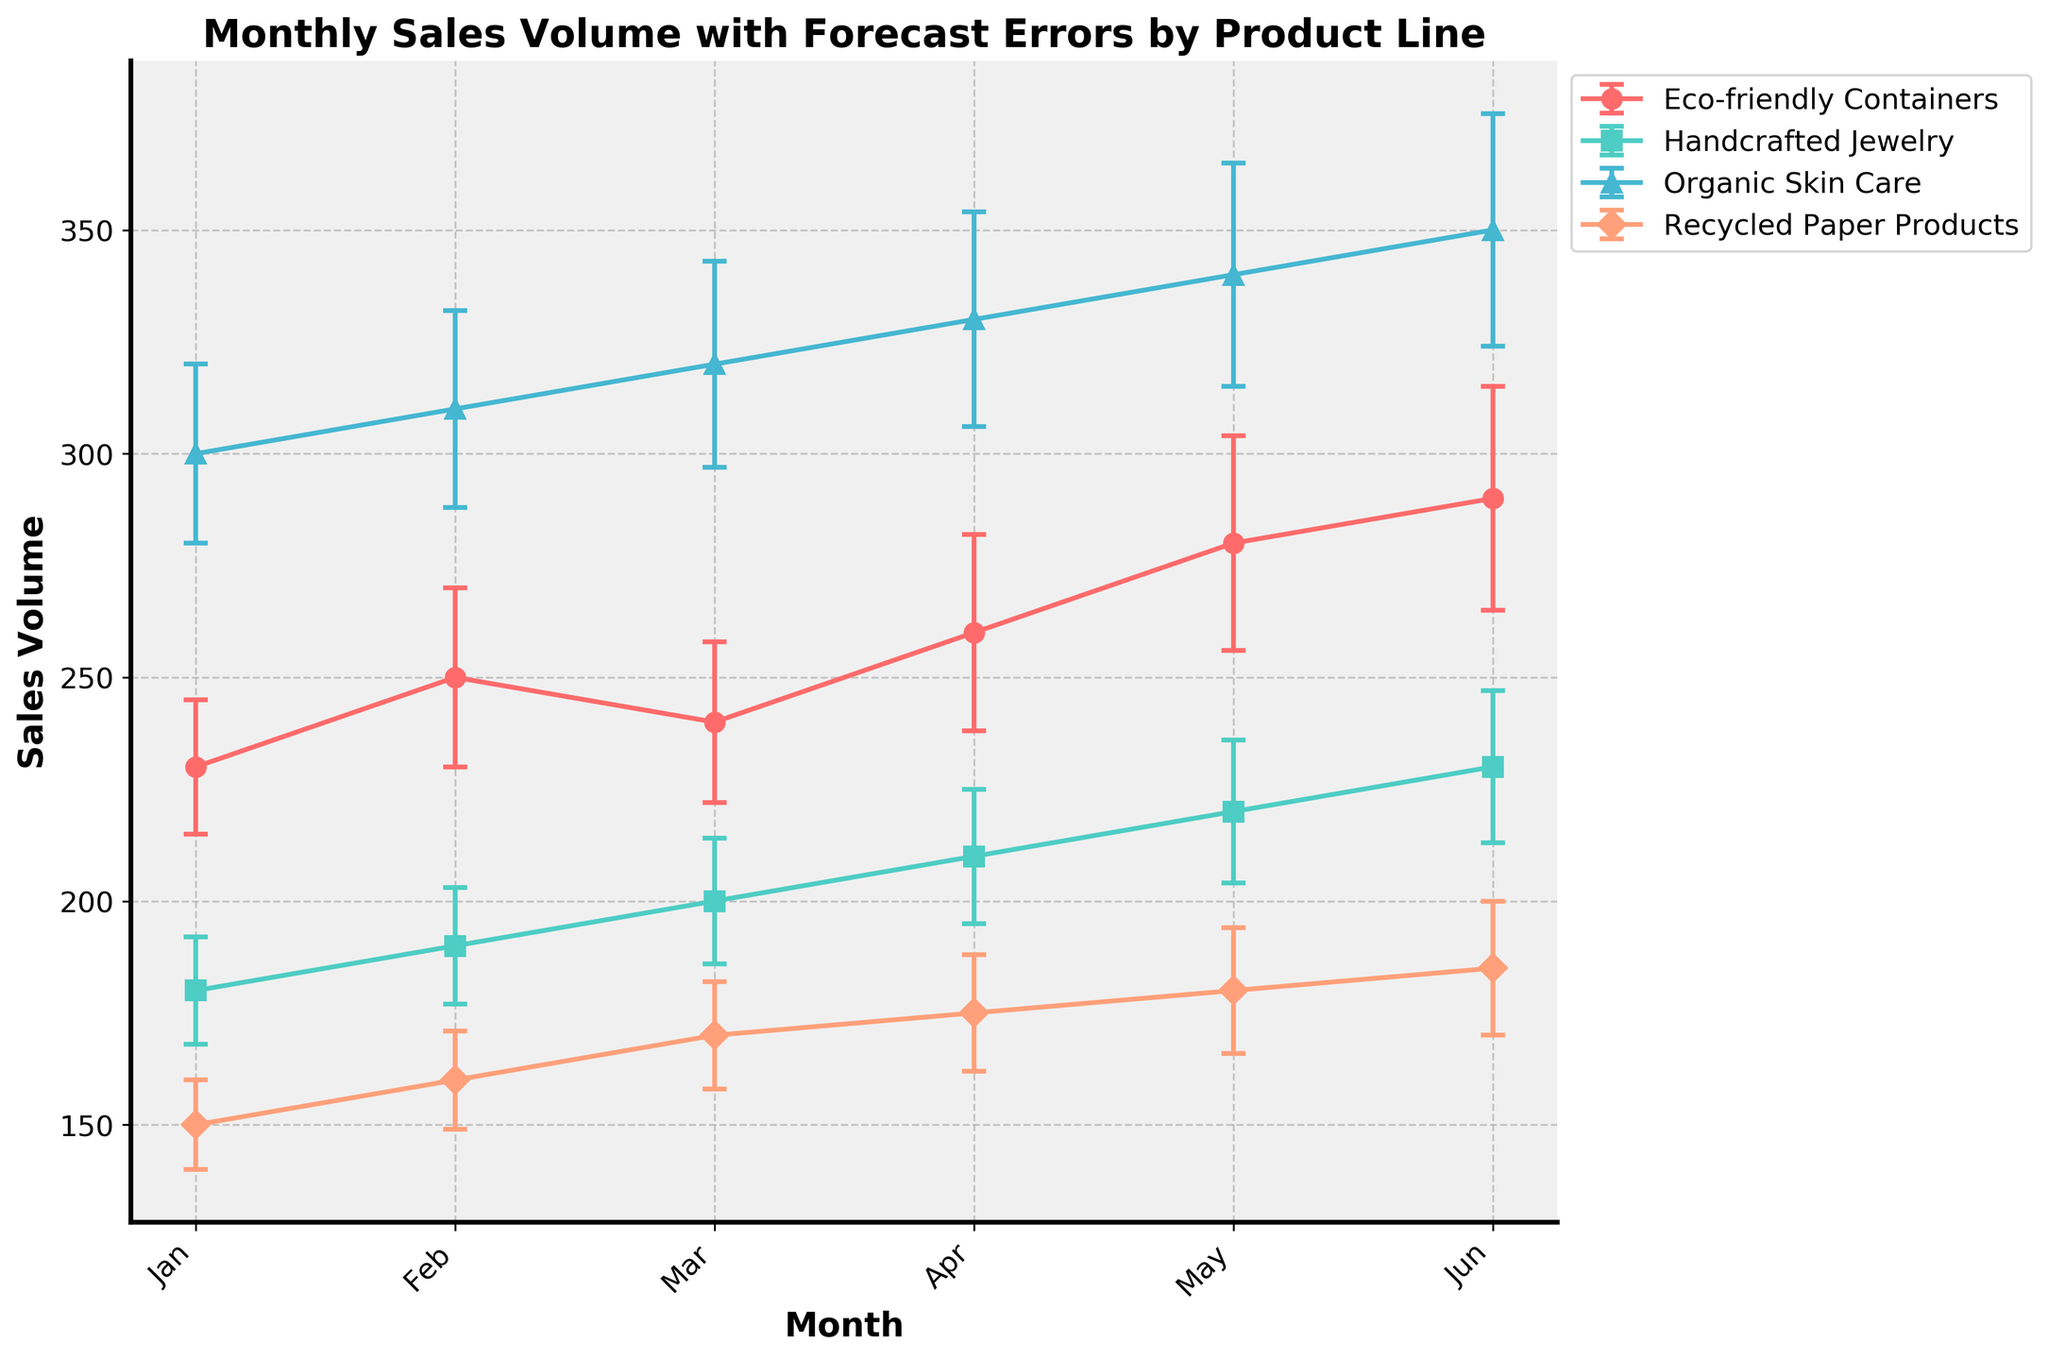What is the title of the plot? The title of the plot is displayed at the top center of the figure. By reading it directly, the title is "Monthly Sales Volume with Forecast Errors by Product Line".
Answer: Monthly Sales Volume with Forecast Errors by Product Line Which product line has the highest sales volume in June? Look at the data points for June on the x-axis and identify which product line has the highest y-value (sales volume). The "Organic Skin Care" line reaches the highest point.
Answer: Organic Skin Care What is the average forecast error for "Handcrafted Jewelry" over the six months? Sum up the forecast errors for "Handcrafted Jewelry" (12, 13, 14, 15, 16, 17) and divide by the number of months (6). (12+13+14+15+16+17)/6 = 87/6 = 14.5
Answer: 14.5 Which month shows the largest forecast error for "Recycled Paper Products"? Check the y-error bars for each month for "Recycled Paper Products". May has the largest error bar length with a forecast error of 14.
Answer: May Compare the sales volumes of "Eco-friendly Containers" in January and February. Which month had higher sales and by how much? Locate the points for "Eco-friendly Containers" in January (230) and February (250). Subtract the January value from the February value: 250 - 230 = 20. February had higher sales by 20 units.
Answer: February, 20 units Is there any product line that shows a decreasing trend in sales volume over time? Examine the trend lines of each product line over all months. None of the product lines visually depict a decreasing trend; they all show an increasing trend.
Answer: No What is the combined sales volume of all product lines in March? Add the sales volumes of all product lines in March: 240 (Eco-friendly Containers) + 200 (Handcrafted Jewelry) + 320 (Organic Skin Care) + 170 (Recycled Paper Products). 240 + 200 + 320 + 170 = 930.
Answer: 930 Which product shows the smallest sales volume fluctuation over the six-month period? Evaluate the range of sales volumes for each product line from January to June. "Recycled Paper Products" has the smallest range (150 - 185 = 35).
Answer: Recycled Paper Products What is the difference in sales volume between "Organic Skin Care" and "Eco-friendly Containers" in April? The sales volume for "Organic Skin Care" in April is 330, and for "Eco-friendly Containers" it is 260. Subtract the value of "Eco-friendly Containers" from "Organic Skin Care": 330 - 260 = 70.
Answer: 70 Which product line had the most consistent forecast errors across the months? Examine the error bars of each product line and find which one maintains the most similar length across all months. "Handcrafted Jewelry" maintains relatively similar error bars ranging from 12 to 17.
Answer: Handcrafted Jewelry 